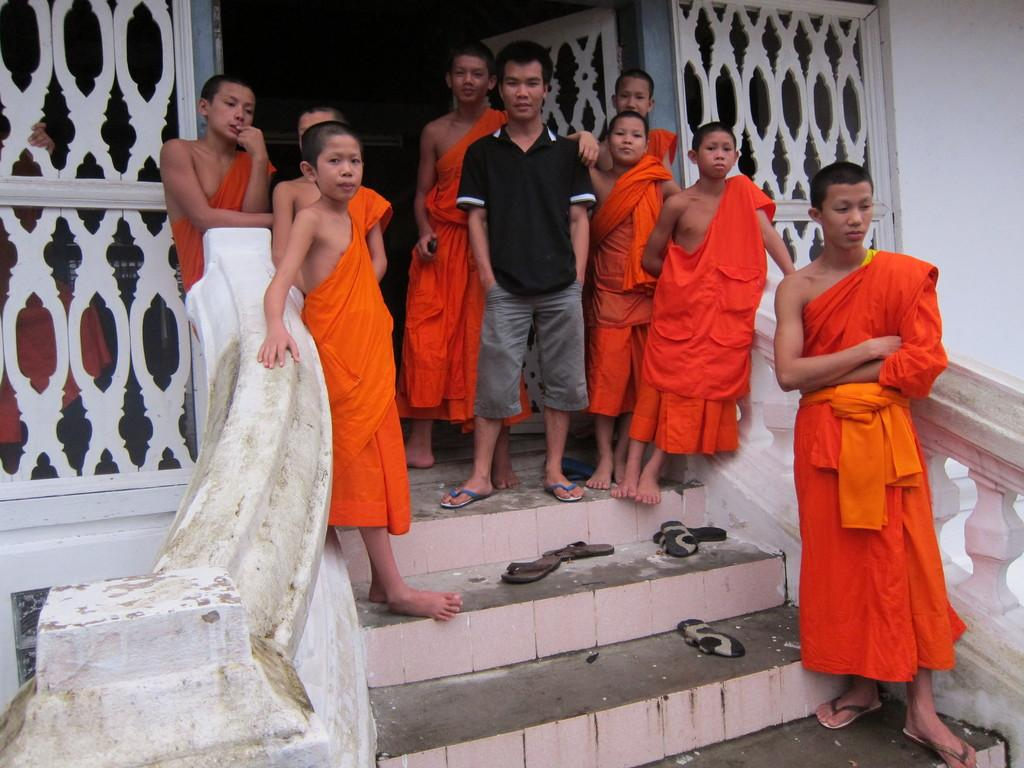What can be seen in the center of the image? There are people standing in the center of the image. What is visible in the background of the image? There is a wall, a railing, and stairs in the background of the image. Are there any objects related to footwear in the image? Yes, there are footwear's in the background of the image. What type of soup is being served to the girls in the image? There are no girls or soup present in the image. 